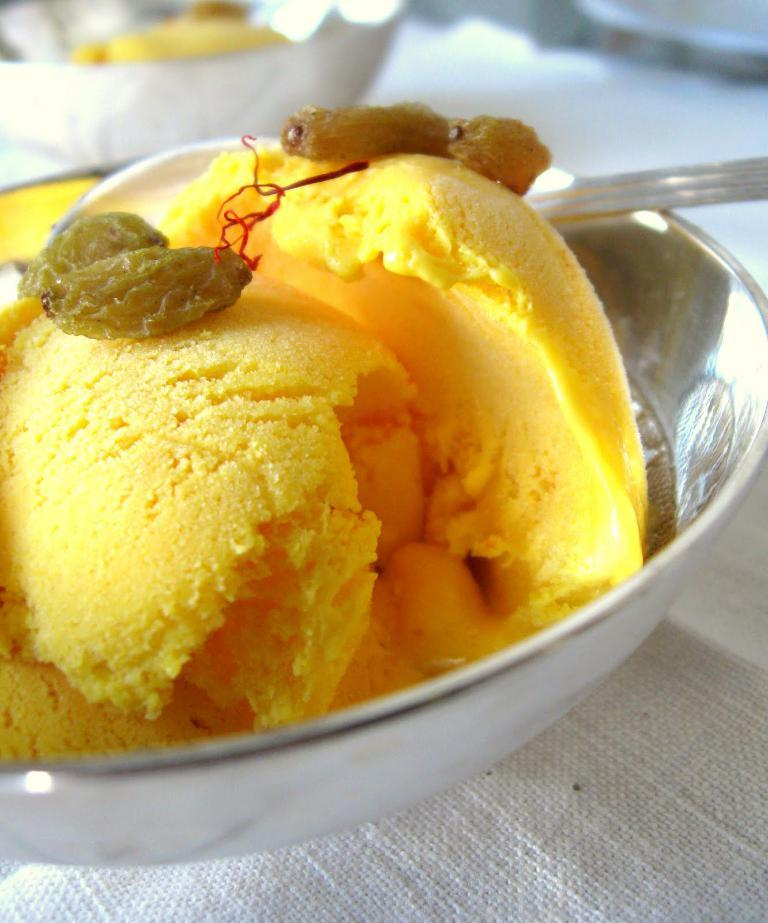What is in the bowl that is visible in the image? There is a bowl of ice cream in the image. What is the main subject of the image? The main subject of the image is the bowl of ice cream. What type of wax can be seen melting on the ice cream in the image? There is no wax present in the image; it is a bowl of ice cream. How many worms are visible on the ice cream in the image? There are no worms present in the image; it is a bowl of ice cream. 